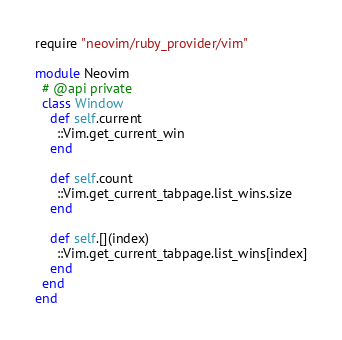Convert code to text. <code><loc_0><loc_0><loc_500><loc_500><_Ruby_>require "neovim/ruby_provider/vim"

module Neovim
  # @api private
  class Window
    def self.current
      ::Vim.get_current_win
    end

    def self.count
      ::Vim.get_current_tabpage.list_wins.size
    end

    def self.[](index)
      ::Vim.get_current_tabpage.list_wins[index]
    end
  end
end
</code> 